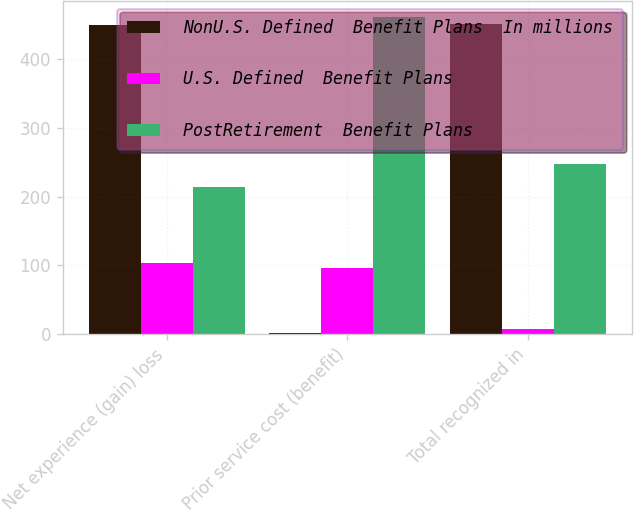<chart> <loc_0><loc_0><loc_500><loc_500><stacked_bar_chart><ecel><fcel>Net experience (gain) loss<fcel>Prior service cost (benefit)<fcel>Total recognized in<nl><fcel>NonU.S. Defined  Benefit Plans  In millions<fcel>450<fcel>1<fcel>451<nl><fcel>U.S. Defined  Benefit Plans<fcel>104<fcel>96<fcel>8<nl><fcel>PostRetirement  Benefit Plans<fcel>214<fcel>462<fcel>248<nl></chart> 